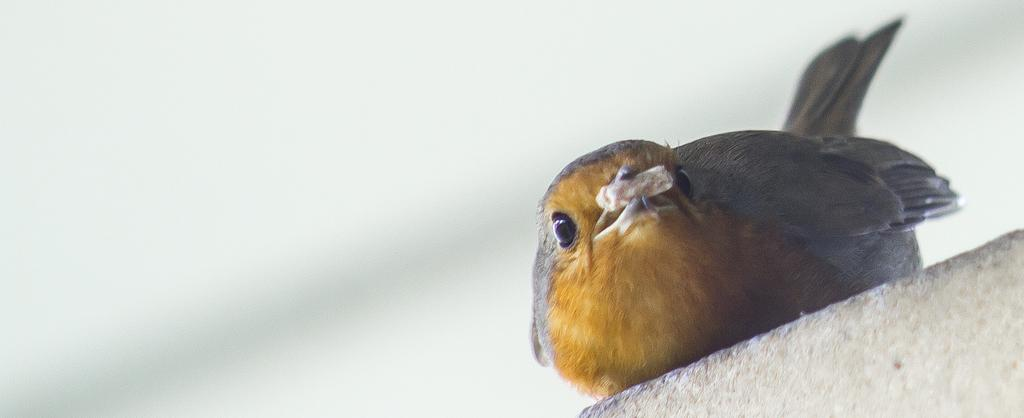What type of animal can be seen in the image? There is a bird in the image. Where is the bird located? The bird is on a wall. What type of meat is the bird preparing on the grill in the image? There is no grill or meat present in the image; it only features a bird on a wall. 